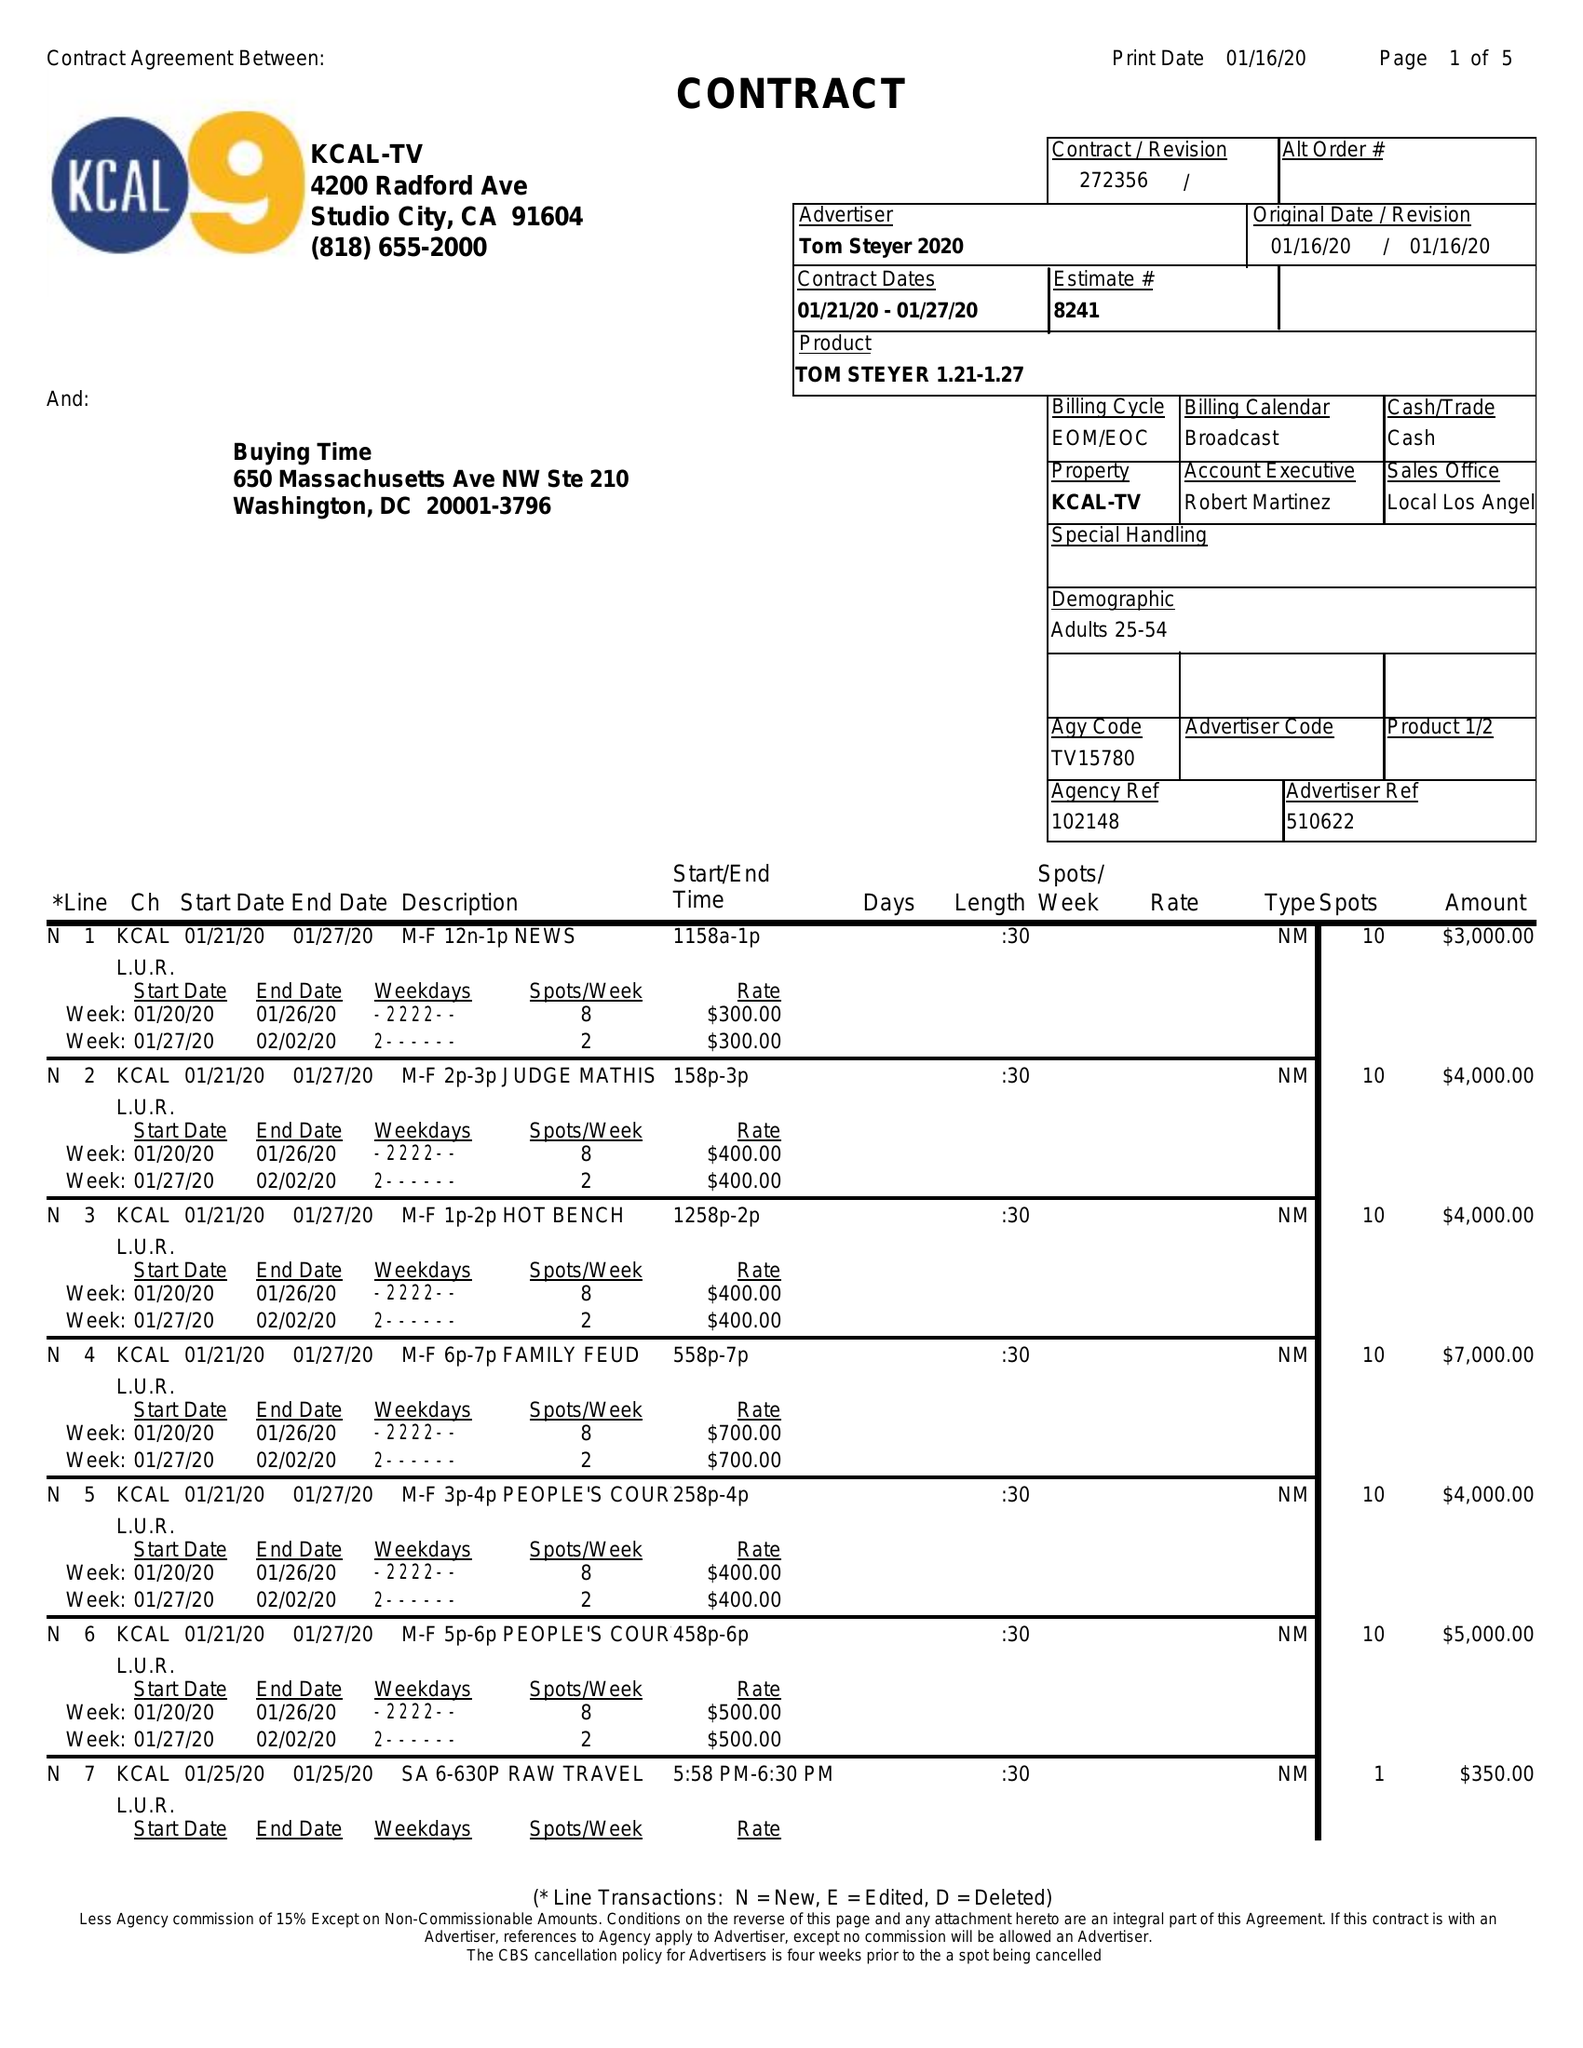What is the value for the flight_from?
Answer the question using a single word or phrase. 01/21/20 